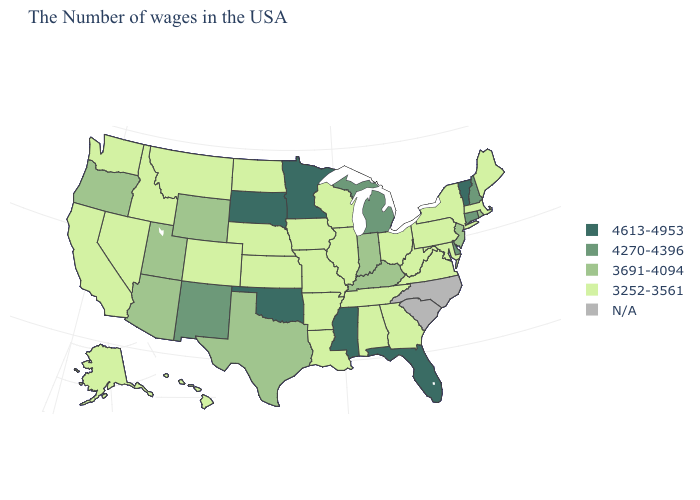Name the states that have a value in the range N/A?
Give a very brief answer. North Carolina, South Carolina. What is the value of Pennsylvania?
Quick response, please. 3252-3561. What is the value of Alaska?
Quick response, please. 3252-3561. Does the map have missing data?
Give a very brief answer. Yes. What is the value of New Jersey?
Keep it brief. 3691-4094. Which states have the lowest value in the South?
Keep it brief. Maryland, Virginia, West Virginia, Georgia, Alabama, Tennessee, Louisiana, Arkansas. Does Arizona have the highest value in the West?
Short answer required. No. How many symbols are there in the legend?
Concise answer only. 5. What is the highest value in the West ?
Concise answer only. 4270-4396. What is the highest value in states that border South Dakota?
Keep it brief. 4613-4953. Does New Jersey have the highest value in the USA?
Short answer required. No. What is the lowest value in the West?
Keep it brief. 3252-3561. What is the highest value in the West ?
Be succinct. 4270-4396. Name the states that have a value in the range 3252-3561?
Be succinct. Maine, Massachusetts, New York, Maryland, Pennsylvania, Virginia, West Virginia, Ohio, Georgia, Alabama, Tennessee, Wisconsin, Illinois, Louisiana, Missouri, Arkansas, Iowa, Kansas, Nebraska, North Dakota, Colorado, Montana, Idaho, Nevada, California, Washington, Alaska, Hawaii. 